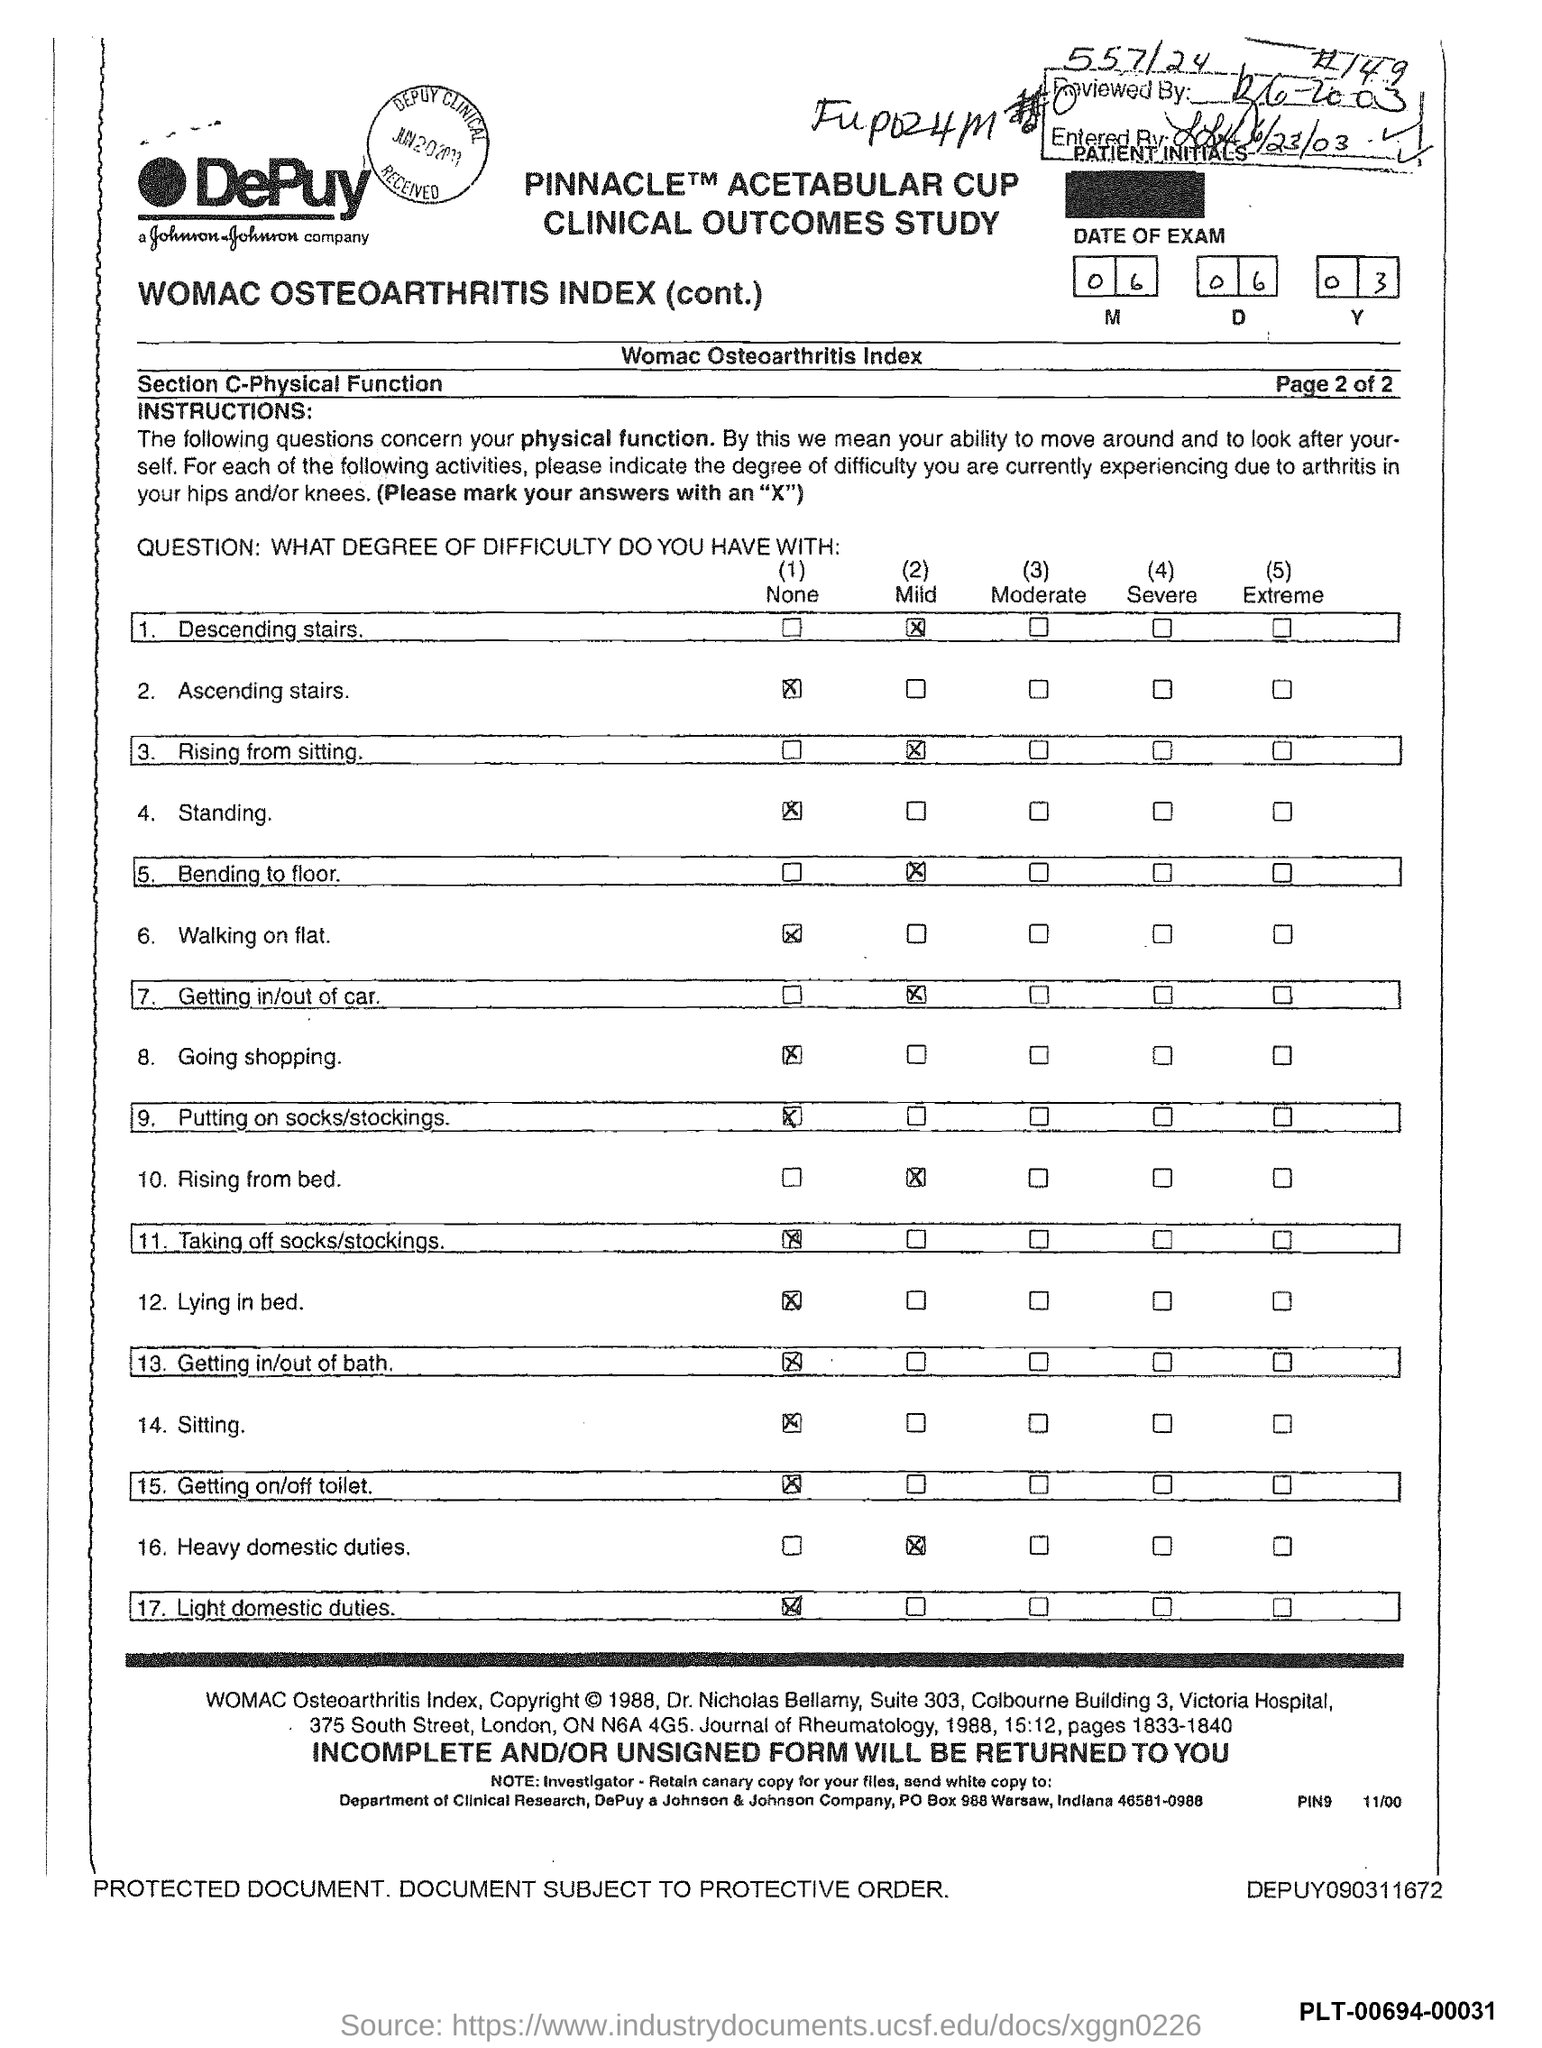Indicate a few pertinent items in this graphic. Johnson & Johnson Company is located in the state of Indiana. The PO box number of Johnson & Johnson Company is 988. 